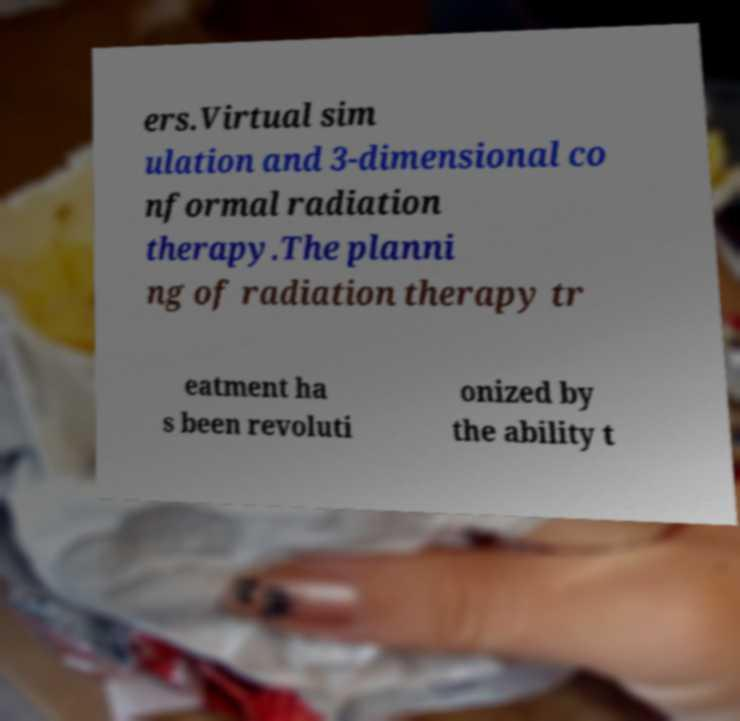Please read and relay the text visible in this image. What does it say? ers.Virtual sim ulation and 3-dimensional co nformal radiation therapy.The planni ng of radiation therapy tr eatment ha s been revoluti onized by the ability t 